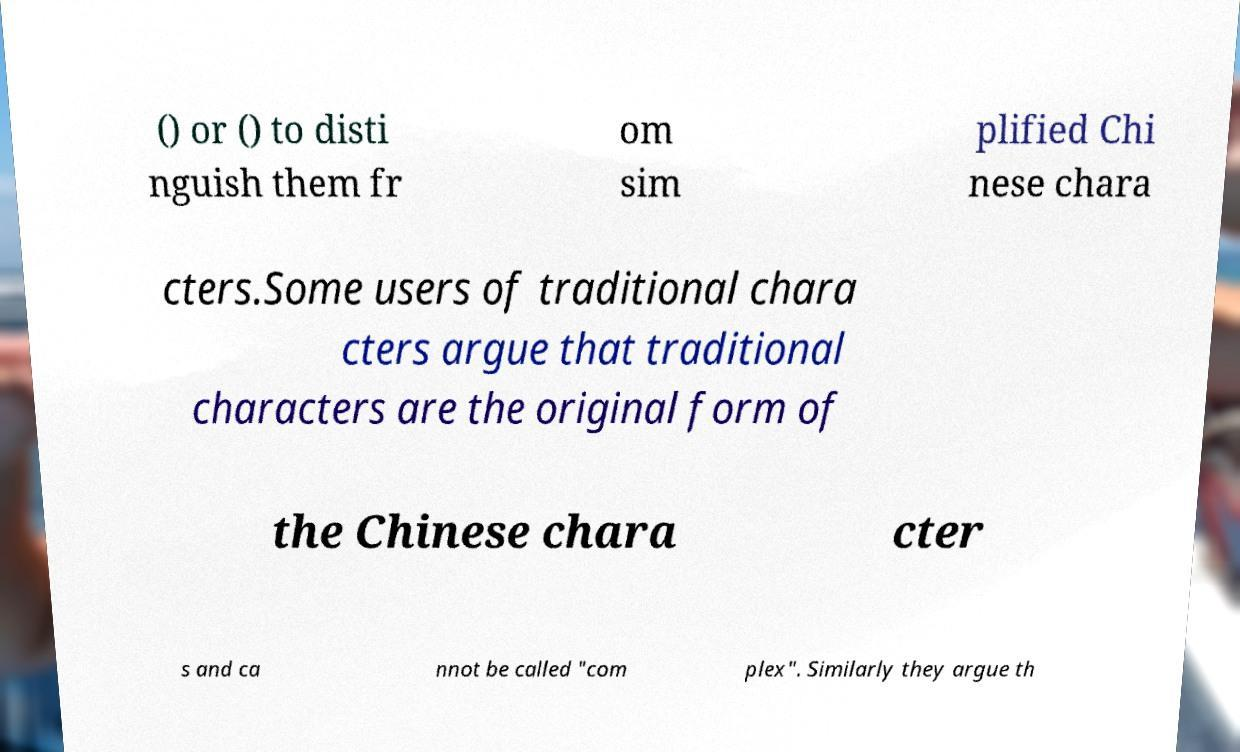There's text embedded in this image that I need extracted. Can you transcribe it verbatim? () or () to disti nguish them fr om sim plified Chi nese chara cters.Some users of traditional chara cters argue that traditional characters are the original form of the Chinese chara cter s and ca nnot be called "com plex". Similarly they argue th 